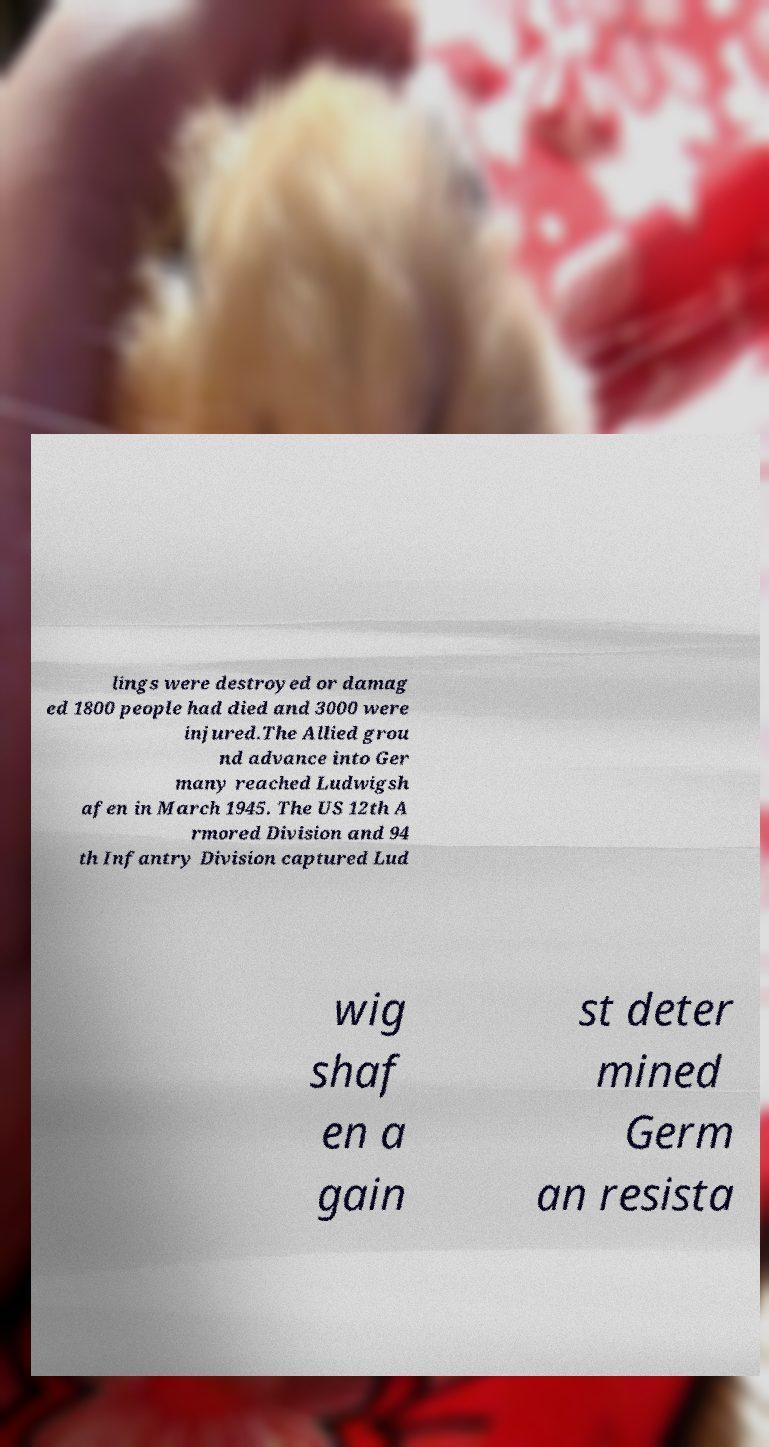Can you accurately transcribe the text from the provided image for me? lings were destroyed or damag ed 1800 people had died and 3000 were injured.The Allied grou nd advance into Ger many reached Ludwigsh afen in March 1945. The US 12th A rmored Division and 94 th Infantry Division captured Lud wig shaf en a gain st deter mined Germ an resista 